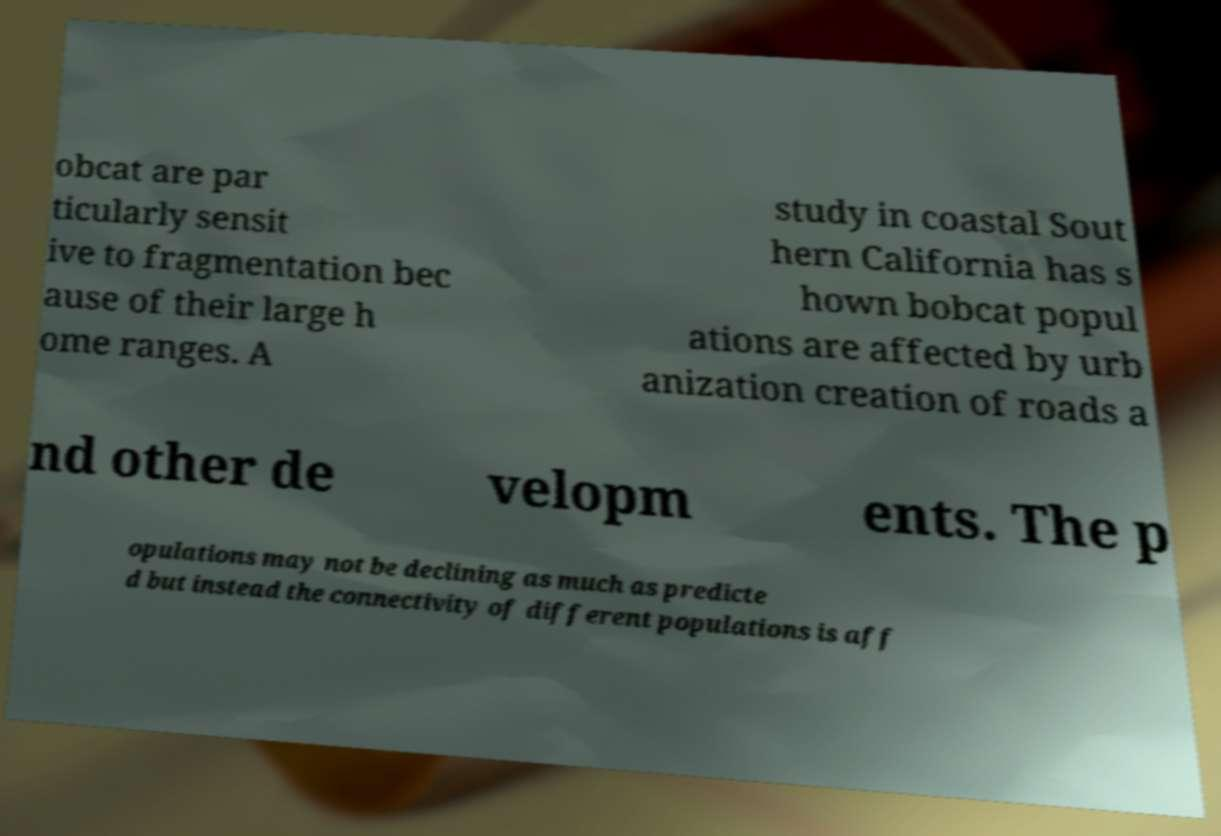Can you read and provide the text displayed in the image?This photo seems to have some interesting text. Can you extract and type it out for me? obcat are par ticularly sensit ive to fragmentation bec ause of their large h ome ranges. A study in coastal Sout hern California has s hown bobcat popul ations are affected by urb anization creation of roads a nd other de velopm ents. The p opulations may not be declining as much as predicte d but instead the connectivity of different populations is aff 